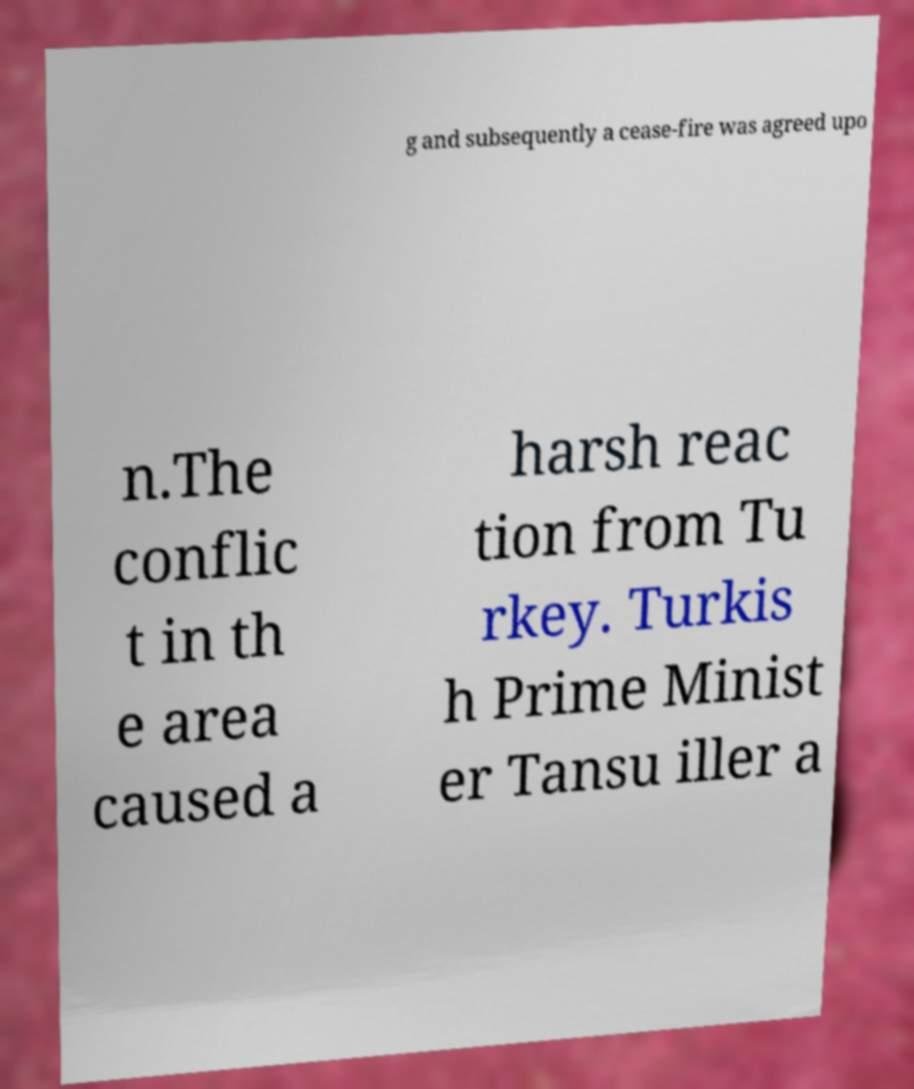What messages or text are displayed in this image? I need them in a readable, typed format. g and subsequently a cease-fire was agreed upo n.The conflic t in th e area caused a harsh reac tion from Tu rkey. Turkis h Prime Minist er Tansu iller a 